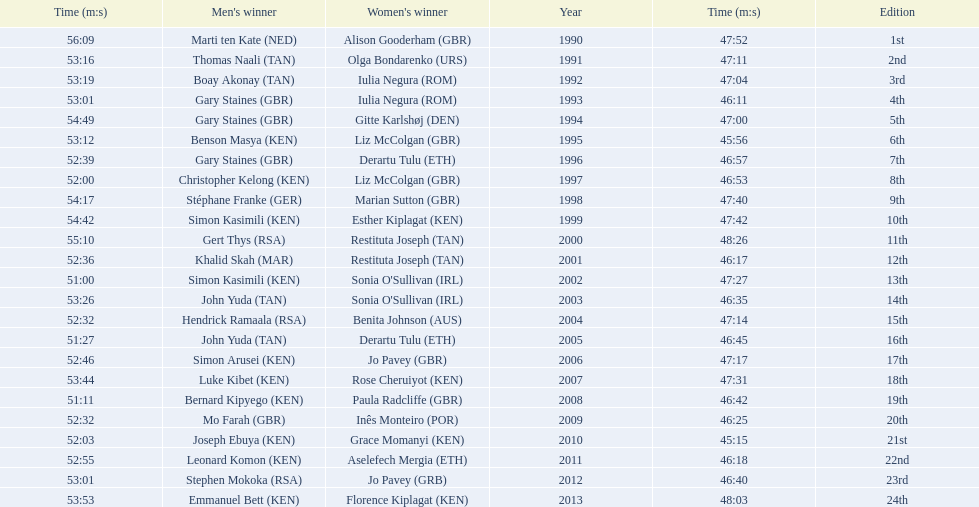What are the names of each male winner? Marti ten Kate (NED), Thomas Naali (TAN), Boay Akonay (TAN), Gary Staines (GBR), Gary Staines (GBR), Benson Masya (KEN), Gary Staines (GBR), Christopher Kelong (KEN), Stéphane Franke (GER), Simon Kasimili (KEN), Gert Thys (RSA), Khalid Skah (MAR), Simon Kasimili (KEN), John Yuda (TAN), Hendrick Ramaala (RSA), John Yuda (TAN), Simon Arusei (KEN), Luke Kibet (KEN), Bernard Kipyego (KEN), Mo Farah (GBR), Joseph Ebuya (KEN), Leonard Komon (KEN), Stephen Mokoka (RSA), Emmanuel Bett (KEN). When did they race? 1990, 1991, 1992, 1993, 1994, 1995, 1996, 1997, 1998, 1999, 2000, 2001, 2002, 2003, 2004, 2005, 2006, 2007, 2008, 2009, 2010, 2011, 2012, 2013. And what were their times? 47:52, 47:11, 47:04, 46:11, 47:00, 45:56, 46:57, 46:53, 47:40, 47:42, 48:26, 46:17, 47:27, 46:35, 47:14, 46:45, 47:17, 47:31, 46:42, 46:25, 45:15, 46:18, 46:40, 48:03. Of those times, which athlete had the fastest time? Joseph Ebuya (KEN). 